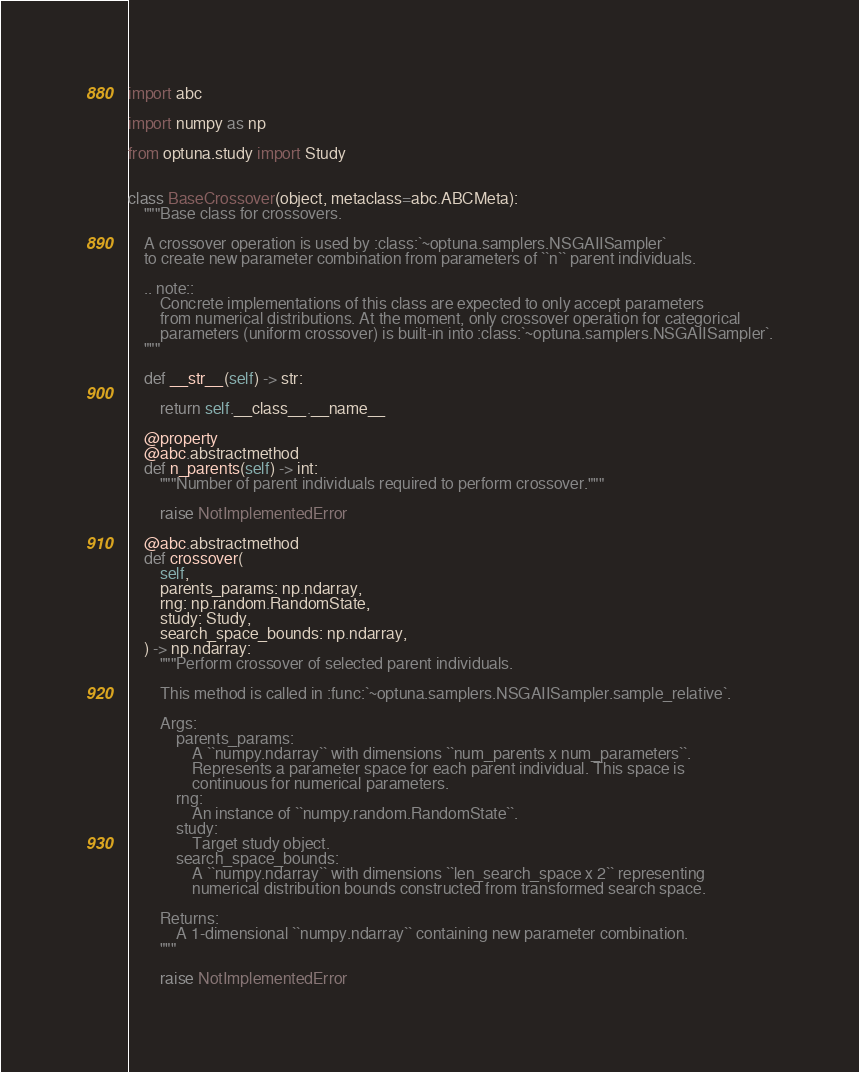<code> <loc_0><loc_0><loc_500><loc_500><_Python_>import abc

import numpy as np

from optuna.study import Study


class BaseCrossover(object, metaclass=abc.ABCMeta):
    """Base class for crossovers.

    A crossover operation is used by :class:`~optuna.samplers.NSGAIISampler`
    to create new parameter combination from parameters of ``n`` parent individuals.

    .. note::
        Concrete implementations of this class are expected to only accept parameters
        from numerical distributions. At the moment, only crossover operation for categorical
        parameters (uniform crossover) is built-in into :class:`~optuna.samplers.NSGAIISampler`.
    """

    def __str__(self) -> str:

        return self.__class__.__name__

    @property
    @abc.abstractmethod
    def n_parents(self) -> int:
        """Number of parent individuals required to perform crossover."""

        raise NotImplementedError

    @abc.abstractmethod
    def crossover(
        self,
        parents_params: np.ndarray,
        rng: np.random.RandomState,
        study: Study,
        search_space_bounds: np.ndarray,
    ) -> np.ndarray:
        """Perform crossover of selected parent individuals.

        This method is called in :func:`~optuna.samplers.NSGAIISampler.sample_relative`.

        Args:
            parents_params:
                A ``numpy.ndarray`` with dimensions ``num_parents x num_parameters``.
                Represents a parameter space for each parent individual. This space is
                continuous for numerical parameters.
            rng:
                An instance of ``numpy.random.RandomState``.
            study:
                Target study object.
            search_space_bounds:
                A ``numpy.ndarray`` with dimensions ``len_search_space x 2`` representing
                numerical distribution bounds constructed from transformed search space.

        Returns:
            A 1-dimensional ``numpy.ndarray`` containing new parameter combination.
        """

        raise NotImplementedError
</code> 